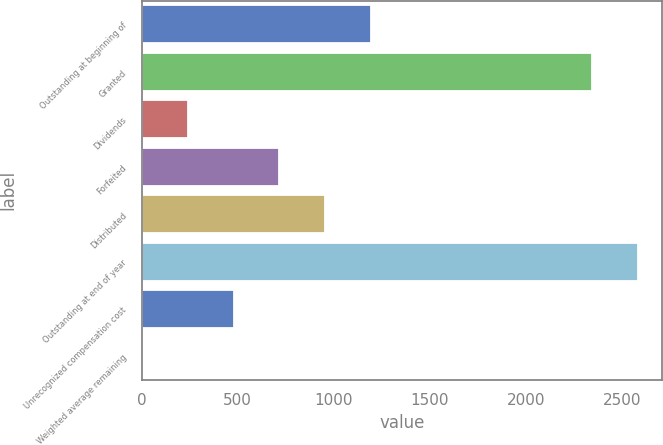<chart> <loc_0><loc_0><loc_500><loc_500><bar_chart><fcel>Outstanding at beginning of<fcel>Granted<fcel>Dividends<fcel>Forfeited<fcel>Distributed<fcel>Outstanding at end of year<fcel>Unrecognized compensation cost<fcel>Weighted average remaining<nl><fcel>1194.05<fcel>2344<fcel>240.49<fcel>717.27<fcel>955.66<fcel>2582.39<fcel>478.88<fcel>2.1<nl></chart> 